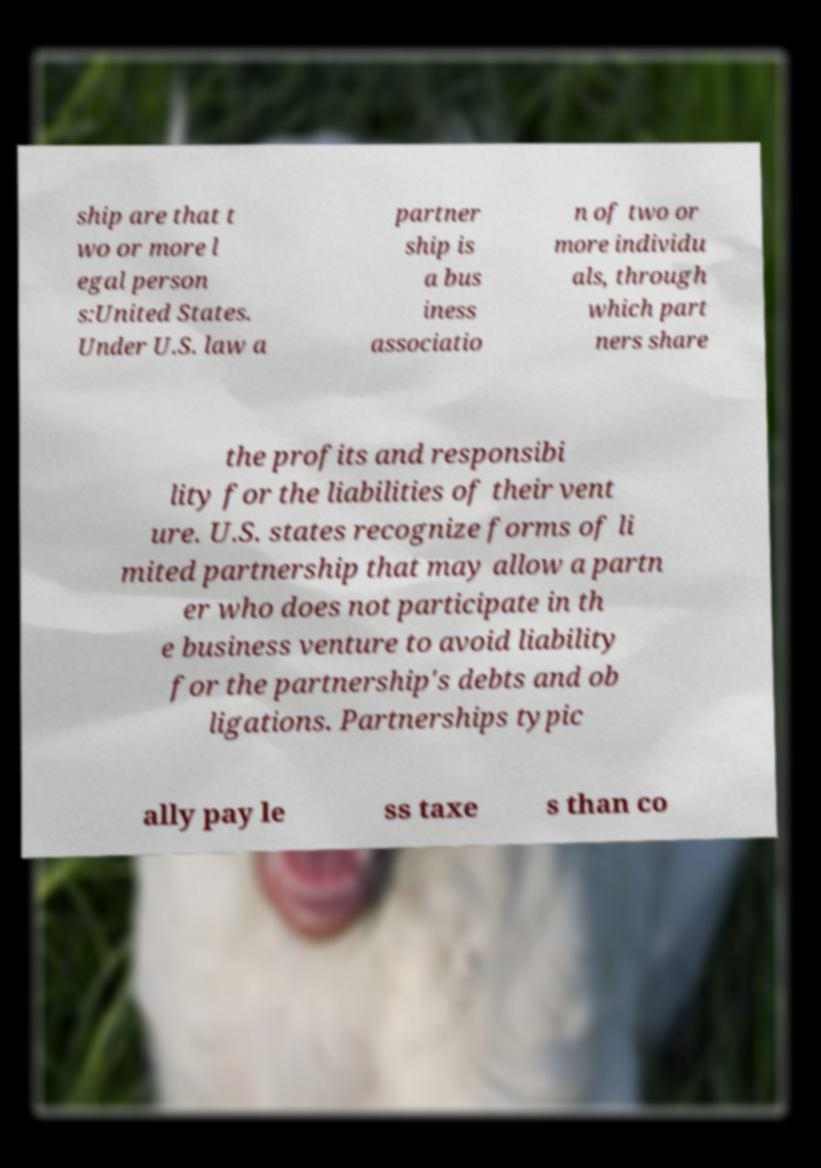Could you assist in decoding the text presented in this image and type it out clearly? ship are that t wo or more l egal person s:United States. Under U.S. law a partner ship is a bus iness associatio n of two or more individu als, through which part ners share the profits and responsibi lity for the liabilities of their vent ure. U.S. states recognize forms of li mited partnership that may allow a partn er who does not participate in th e business venture to avoid liability for the partnership's debts and ob ligations. Partnerships typic ally pay le ss taxe s than co 